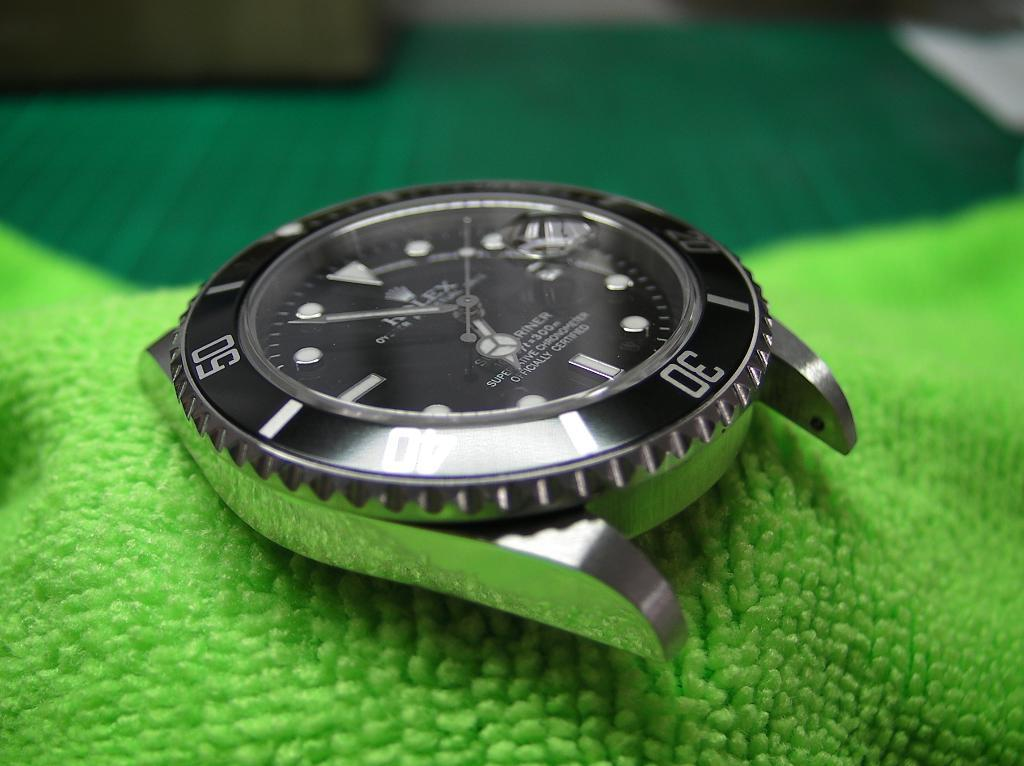<image>
Offer a succinct explanation of the picture presented. A watch face on a green cloth that is officially certified. 